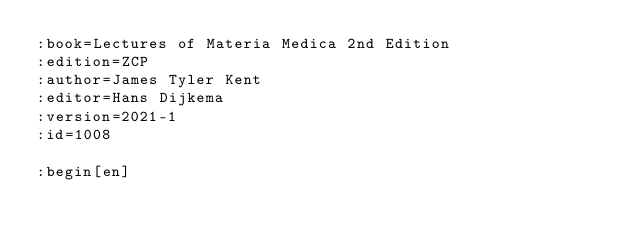Convert code to text. <code><loc_0><loc_0><loc_500><loc_500><_ObjectiveC_>:book=Lectures of Materia Medica 2nd Edition
:edition=ZCP
:author=James Tyler Kent
:editor=Hans Dijkema
:version=2021-1
:id=1008

:begin[en]




</code> 